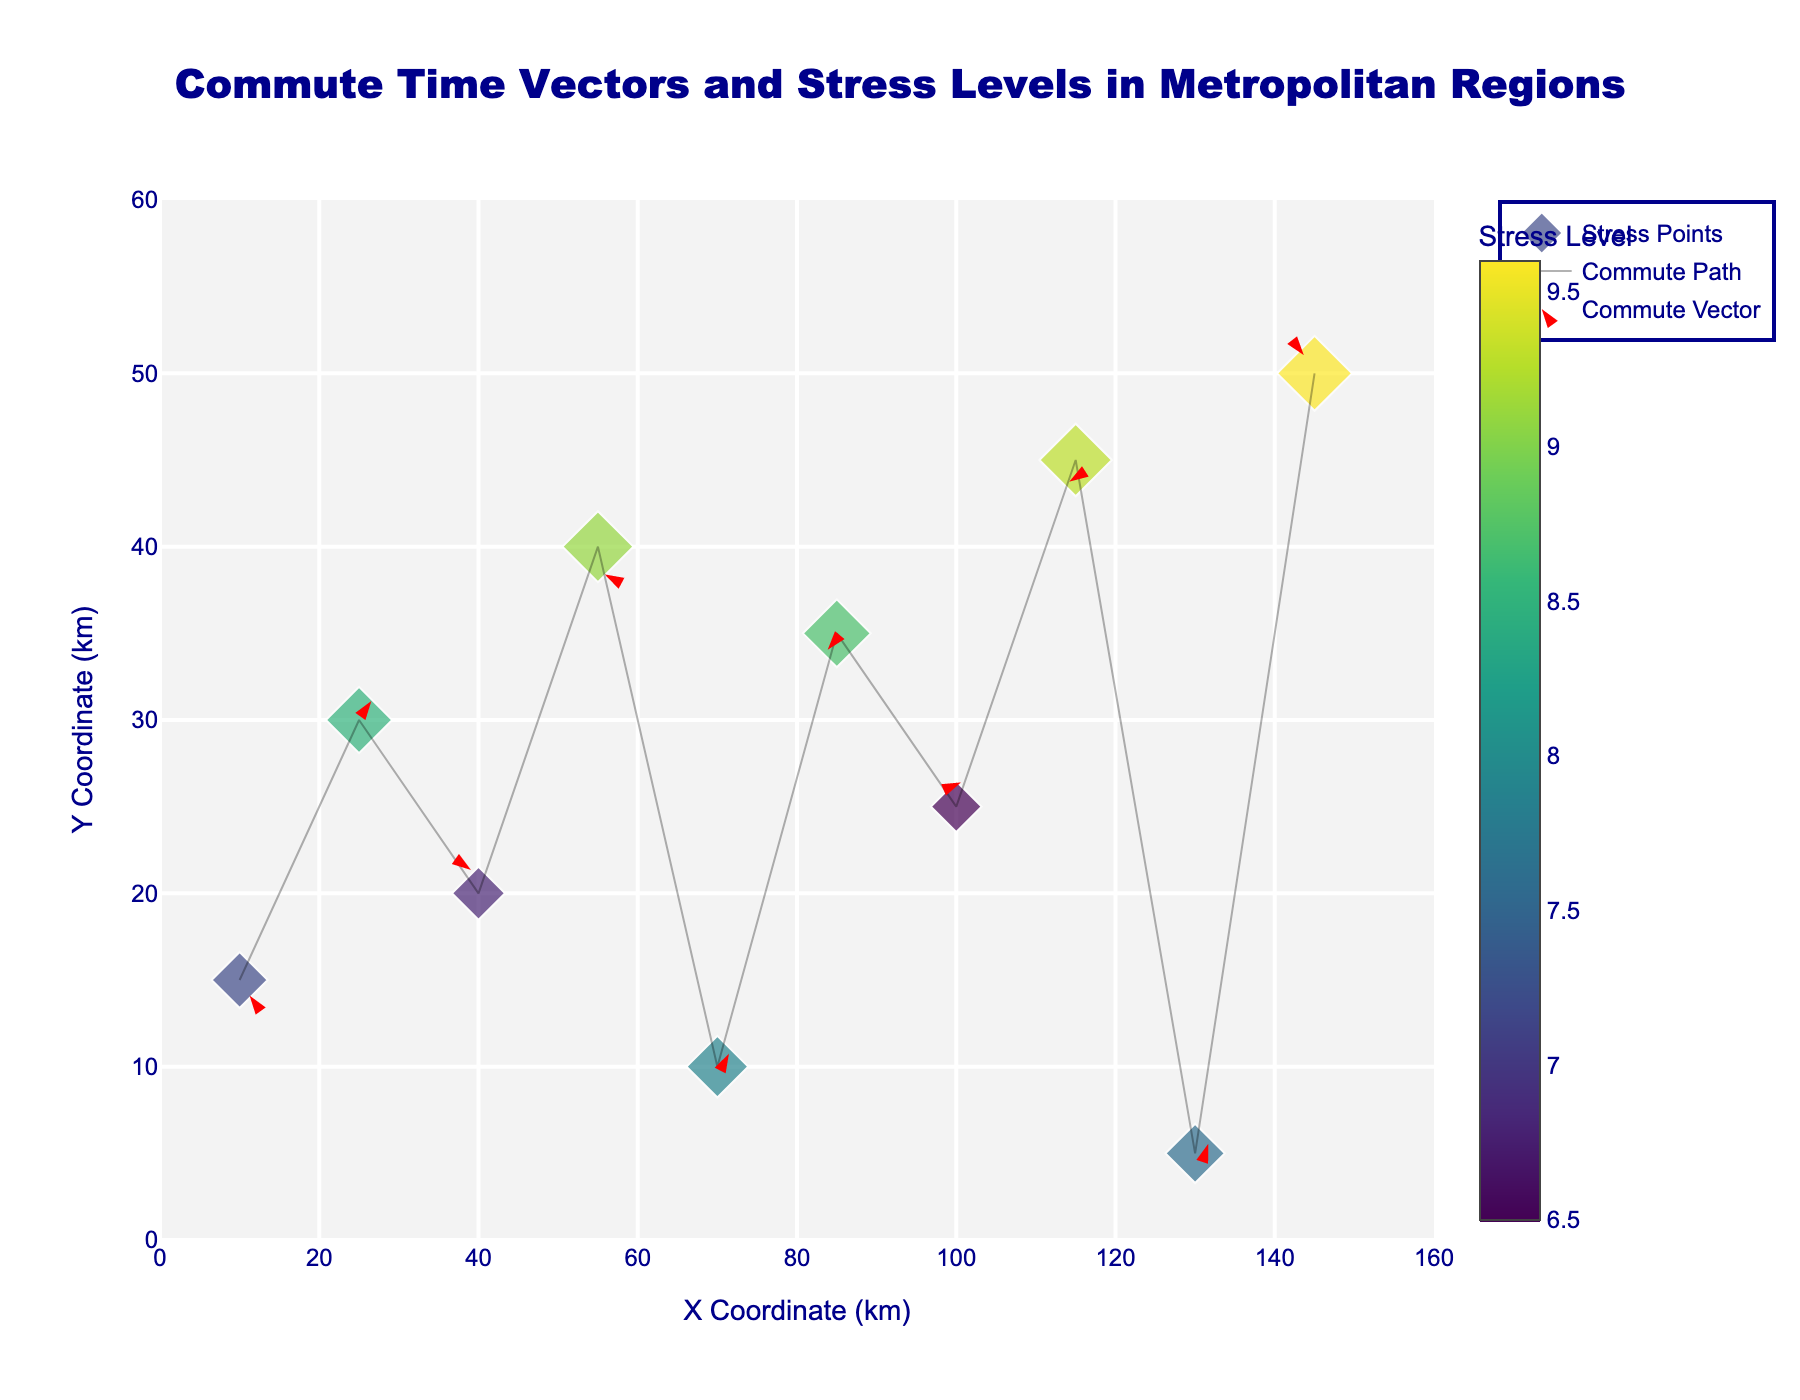How many data points are displayed in the figure? The figure shows data points that are represented by diamond markers. Counting the number of these markers tells us the number of data points.
Answer: 10 What is the color scale used to indicate the stress level? The markers in the figure use a color scale to represent the stress level, which is indicated by the color legend in the figure. The color scale is Viridis, a gradient from purple to yellow.
Answer: Viridis Which data point has the highest stress level? The data point with the highest stress level can be identified by looking at the color of the markers and checking the value associated with the brightest marker, as well as the size of the marker. The data point at (145, 50) has the highest stress level, indicated by the color and size of the marker.
Answer: (145, 50) What is the general trend in the direction of commute vectors? By observing the direction of the arrows (commute vectors) in the quiver plot, we can identify the general trend of their movement. Most of the vectors point in varied directions, but a significant number have components moving either horizontally or vertically.
Answer: Varied directions, significant horizontal and vertical components Which data point has the shortest arrow (commute vector)? To find the data point with the shortest commute vector, we need to look for the smallest arrow among all the vectors displayed in the figure. The data point at (100, 25) has the shortest arrow.
Answer: (100, 25) Which area (x, y) coordinate appears to have the highest concentration of stress levels? By observing the concentration of large, bright color markers, we can find the area with the highest concentration of high stress levels. The coordinates around (55, 40) and (145, 50) seem to have the highest concentration of high stress levels.
Answer: Around (55, 40) and (145, 50) Do larger stress levels correlate with longer commute vectors? To determine if there is a correlation, we must compare the size of stress level markers with the length of the commute vectors. Observing the vectors, longer arrows are associated with both high and low stress levels, suggesting no consistent correlation.
Answer: No consistent correlation What is the average stress level of all data points in the figure? Summing up all the stress level values and dividing by the number of data points: (7.2 + 8.5 + 6.8 + 9.1 + 7.9 + 8.7 + 6.5 + 9.3 + 7.6 + 9.6) / 10 = 8.12.
Answer: 8.12 